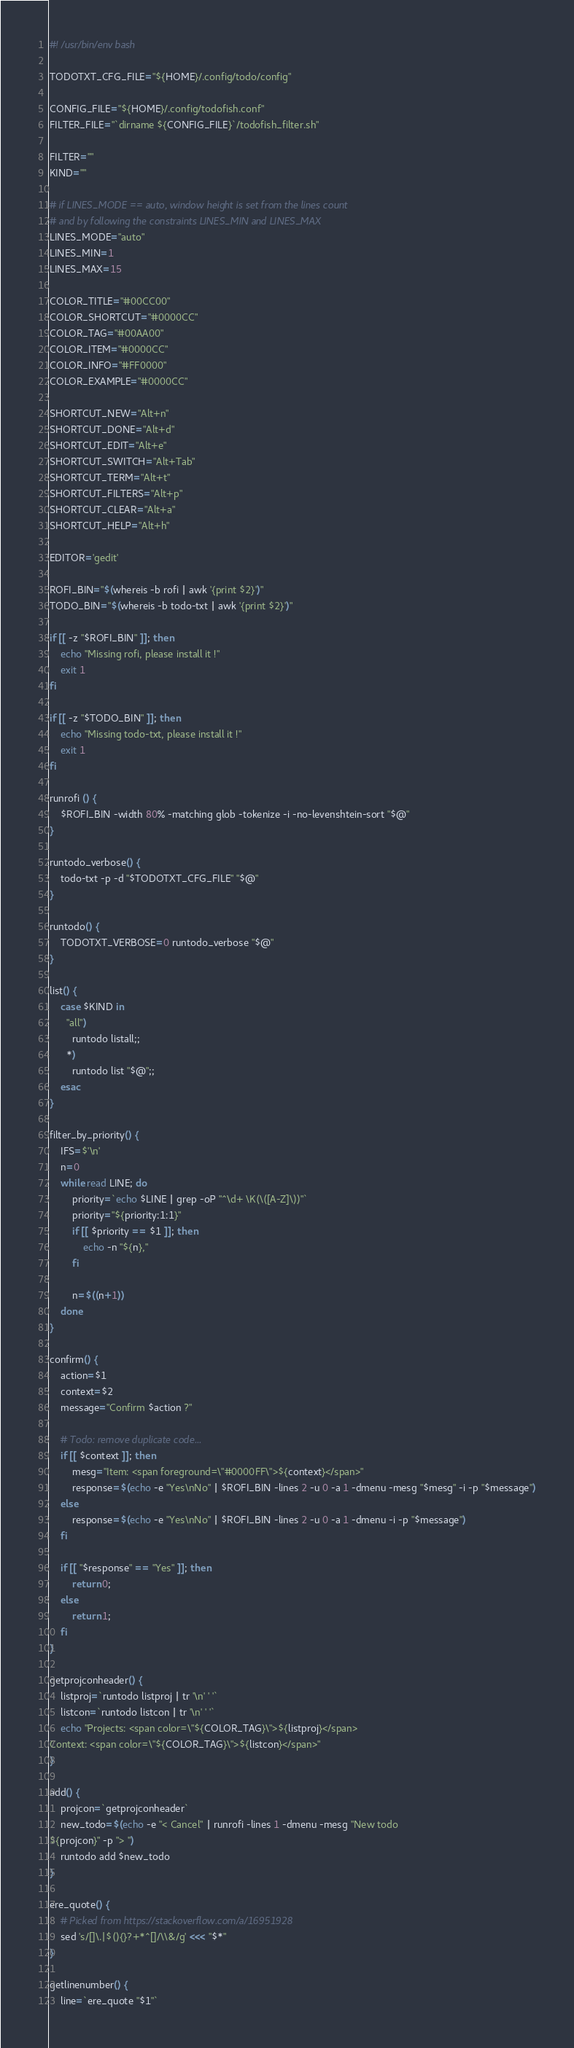Convert code to text. <code><loc_0><loc_0><loc_500><loc_500><_Bash_>#! /usr/bin/env bash

TODOTXT_CFG_FILE="${HOME}/.config/todo/config"

CONFIG_FILE="${HOME}/.config/todofish.conf"
FILTER_FILE="`dirname ${CONFIG_FILE}`/todofish_filter.sh"

FILTER=""
KIND=""

# if LINES_MODE == auto, window height is set from the lines count
# and by following the constraints LINES_MIN and LINES_MAX
LINES_MODE="auto"
LINES_MIN=1
LINES_MAX=15

COLOR_TITLE="#00CC00"
COLOR_SHORTCUT="#0000CC"
COLOR_TAG="#00AA00"
COLOR_ITEM="#0000CC"
COLOR_INFO="#FF0000"
COLOR_EXAMPLE="#0000CC"

SHORTCUT_NEW="Alt+n"
SHORTCUT_DONE="Alt+d"
SHORTCUT_EDIT="Alt+e"
SHORTCUT_SWITCH="Alt+Tab"
SHORTCUT_TERM="Alt+t"
SHORTCUT_FILTERS="Alt+p"
SHORTCUT_CLEAR="Alt+a"
SHORTCUT_HELP="Alt+h"

EDITOR='gedit'

ROFI_BIN="$(whereis -b rofi | awk '{print $2}')"
TODO_BIN="$(whereis -b todo-txt | awk '{print $2}')"

if [[ -z "$ROFI_BIN" ]]; then
    echo "Missing rofi, please install it !"
    exit 1
fi

if [[ -z "$TODO_BIN" ]]; then
    echo "Missing todo-txt, please install it !"
    exit 1
fi

runrofi () {
    $ROFI_BIN -width 80% -matching glob -tokenize -i -no-levenshtein-sort "$@"
}

runtodo_verbose() {
    todo-txt -p -d "$TODOTXT_CFG_FILE" "$@"
}

runtodo() {
    TODOTXT_VERBOSE=0 runtodo_verbose "$@"
}

list() {
    case $KIND in
      "all")
        runtodo listall;;
      *)
        runtodo list "$@";;
    esac
}

filter_by_priority() {
    IFS=$'\n'
    n=0
    while read LINE; do
        priority=`echo $LINE | grep -oP "^\d+ \K(\([A-Z]\))"`
        priority="${priority:1:1}"
        if [[ $priority == $1 ]]; then
            echo -n "${n},"
        fi

        n=$((n+1))
    done
}

confirm() {
    action=$1
    context=$2
    message="Confirm $action ?"

    # Todo: remove duplicate code...
    if [[ $context ]]; then
        mesg="Item: <span foreground=\"#0000FF\">${context}</span>"
        response=$(echo -e "Yes\nNo" | $ROFI_BIN -lines 2 -u 0 -a 1 -dmenu -mesg "$mesg" -i -p "$message")
    else
        response=$(echo -e "Yes\nNo" | $ROFI_BIN -lines 2 -u 0 -a 1 -dmenu -i -p "$message")
    fi

    if [[ "$response" == "Yes" ]]; then
        return 0;
    else
        return 1;
    fi
}

getprojconheader() {
    listproj=`runtodo listproj | tr '\n' ' '`
    listcon=`runtodo listcon | tr '\n' ' '`
    echo "Projects: <span color=\"${COLOR_TAG}\">${listproj}</span>
Context: <span color=\"${COLOR_TAG}\">${listcon}</span>"
}

add() {
    projcon=`getprojconheader`
    new_todo=$(echo -e "< Cancel" | runrofi -lines 1 -dmenu -mesg "New todo
${projcon}" -p "> ")
    runtodo add $new_todo
}

ere_quote() {
    # Picked from https://stackoverflow.com/a/16951928
    sed 's/[]\.|$(){}?+*^[]/\\&/g' <<< "$*"
}

getlinenumber() {
    line=`ere_quote "$1"`</code> 